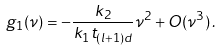<formula> <loc_0><loc_0><loc_500><loc_500>g _ { 1 } ( \nu ) = - \frac { k _ { 2 } } { k _ { 1 } t _ { ( l + 1 ) d } } \nu ^ { 2 } + O ( \nu ^ { 3 } ) \, .</formula> 